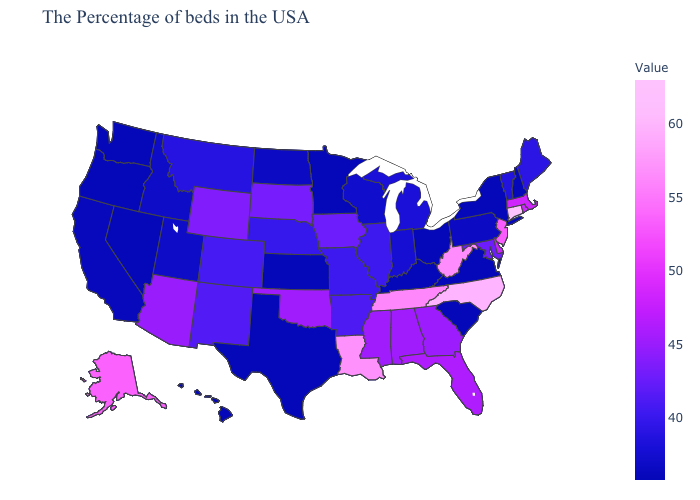Among the states that border Pennsylvania , does Maryland have the highest value?
Concise answer only. No. Does Illinois have the highest value in the USA?
Be succinct. No. Does Hawaii have the highest value in the West?
Keep it brief. No. Among the states that border Colorado , does Kansas have the highest value?
Give a very brief answer. No. Does Alaska have a lower value than Pennsylvania?
Be succinct. No. Which states have the lowest value in the USA?
Quick response, please. New Hampshire, New York, Virginia, South Carolina, Ohio, Kentucky, Minnesota, Kansas, Texas, Nevada, Washington, Oregon, Hawaii. Does New York have the highest value in the Northeast?
Answer briefly. No. Which states have the lowest value in the South?
Quick response, please. Virginia, South Carolina, Kentucky, Texas. 